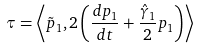<formula> <loc_0><loc_0><loc_500><loc_500>\tau = \left \langle { \tilde { p } } _ { 1 } , 2 \left ( \frac { d p _ { 1 } } { d t } + \frac { { \hat { \gamma } } _ { 1 } } { 2 } p _ { 1 } \right ) \right \rangle</formula> 